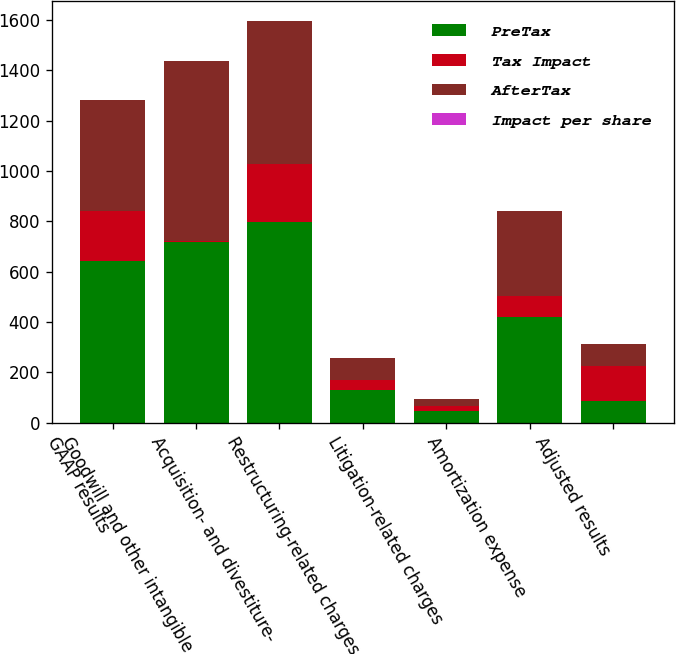Convert chart to OTSL. <chart><loc_0><loc_0><loc_500><loc_500><stacked_bar_chart><ecel><fcel>GAAP results<fcel>Goodwill and other intangible<fcel>Acquisition- and divestiture-<fcel>Restructuring-related charges<fcel>Litigation-related charges<fcel>Amortization expense<fcel>Adjusted results<nl><fcel>PreTax<fcel>642<fcel>718<fcel>798<fcel>129<fcel>48<fcel>421<fcel>85.5<nl><fcel>Tax Impact<fcel>201<fcel>5<fcel>229<fcel>39<fcel>18<fcel>81<fcel>142<nl><fcel>AfterTax<fcel>441<fcel>713<fcel>569<fcel>90<fcel>30<fcel>340<fcel>85.5<nl><fcel>Impact per share<fcel>0.29<fcel>0.47<fcel>0.37<fcel>0.06<fcel>0.02<fcel>0.22<fcel>0.67<nl></chart> 